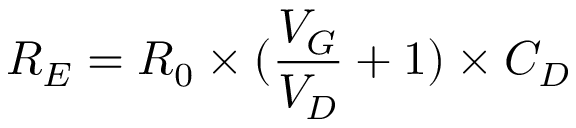Convert formula to latex. <formula><loc_0><loc_0><loc_500><loc_500>R _ { E } = R _ { 0 } \times ( \frac { V _ { G } } { V _ { D } } + 1 ) \times C _ { D }</formula> 